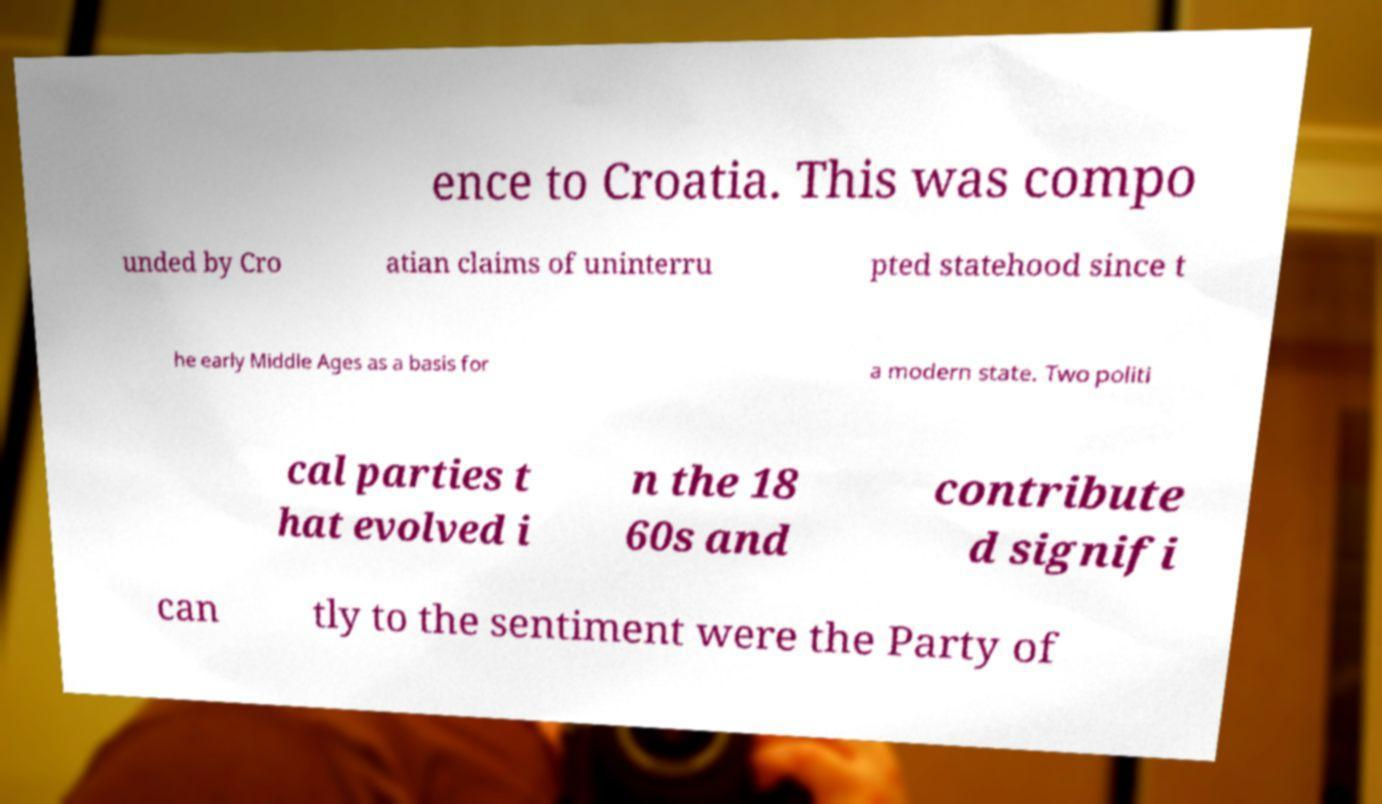Could you extract and type out the text from this image? ence to Croatia. This was compo unded by Cro atian claims of uninterru pted statehood since t he early Middle Ages as a basis for a modern state. Two politi cal parties t hat evolved i n the 18 60s and contribute d signifi can tly to the sentiment were the Party of 